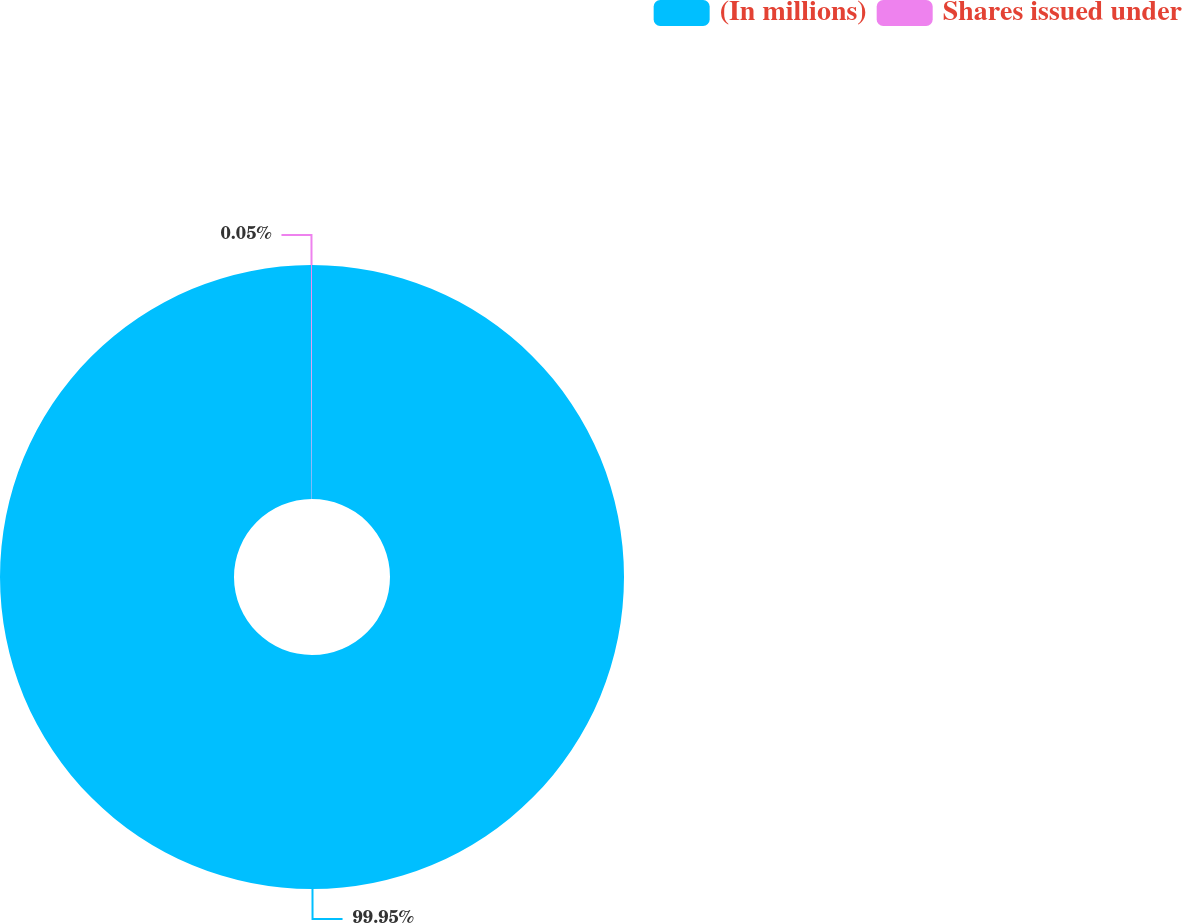Convert chart. <chart><loc_0><loc_0><loc_500><loc_500><pie_chart><fcel>(In millions)<fcel>Shares issued under<nl><fcel>99.95%<fcel>0.05%<nl></chart> 